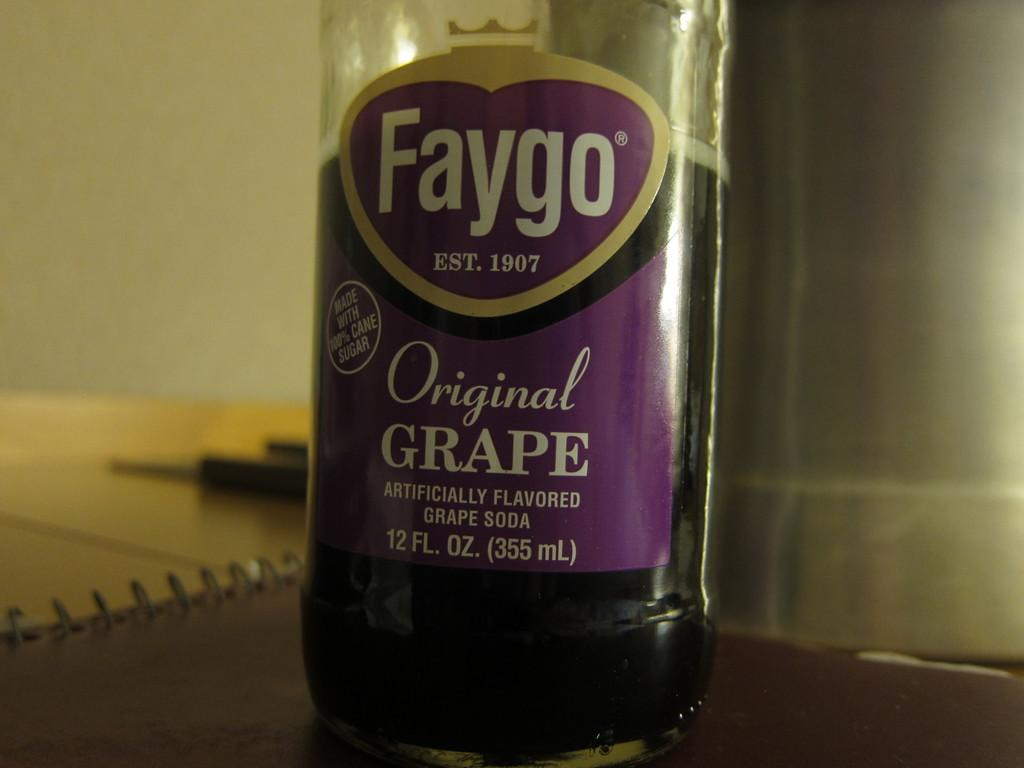<image>
Share a concise interpretation of the image provided. A 12 ounce bottle of Faygo grape soda. 